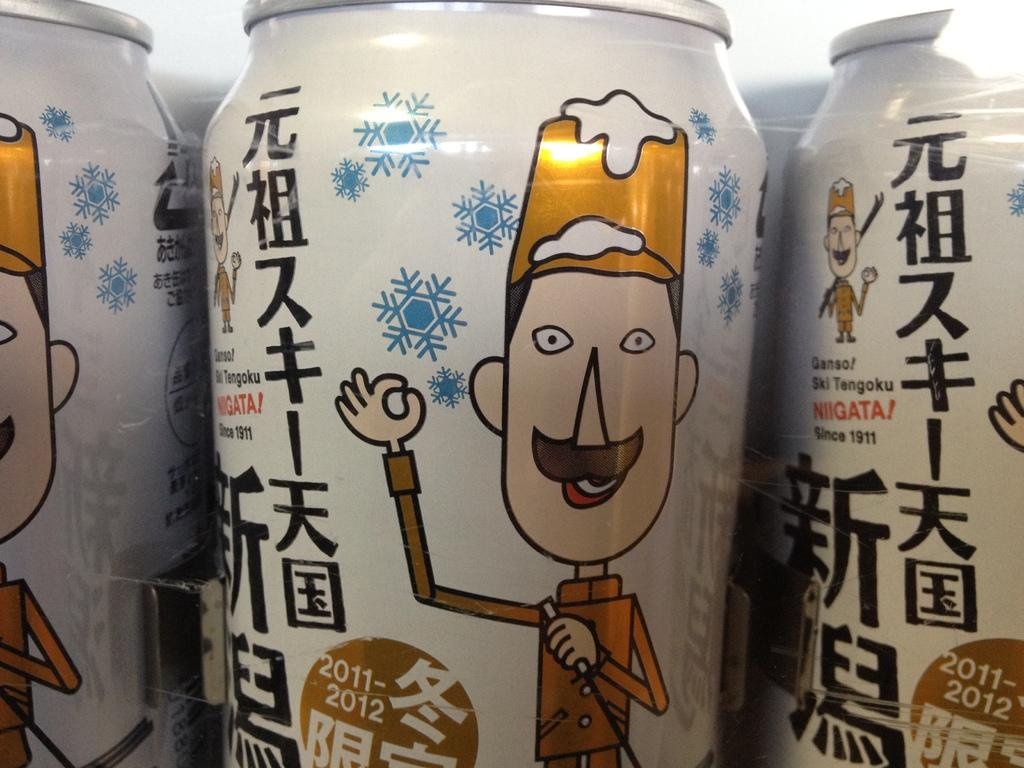What objects are present in the image? There are tins in the image. What is the color of the tins? The tins are white in color. What is depicted on the tins? There is a picture of a man on the tins. What else can be seen on the tins? There is text on the tins. What type of quince is being used in the operation depicted in the image? There is no quince or operation present in the image; it features tins with a picture of a man and text. 